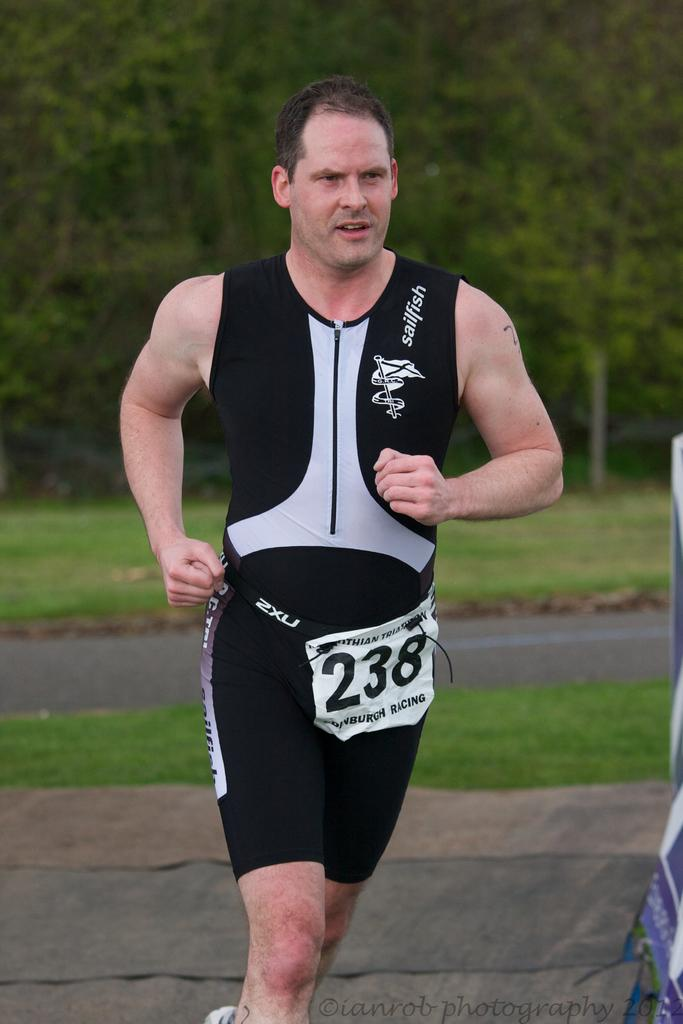<image>
Write a terse but informative summary of the picture. a man that has 238 written on his pants 